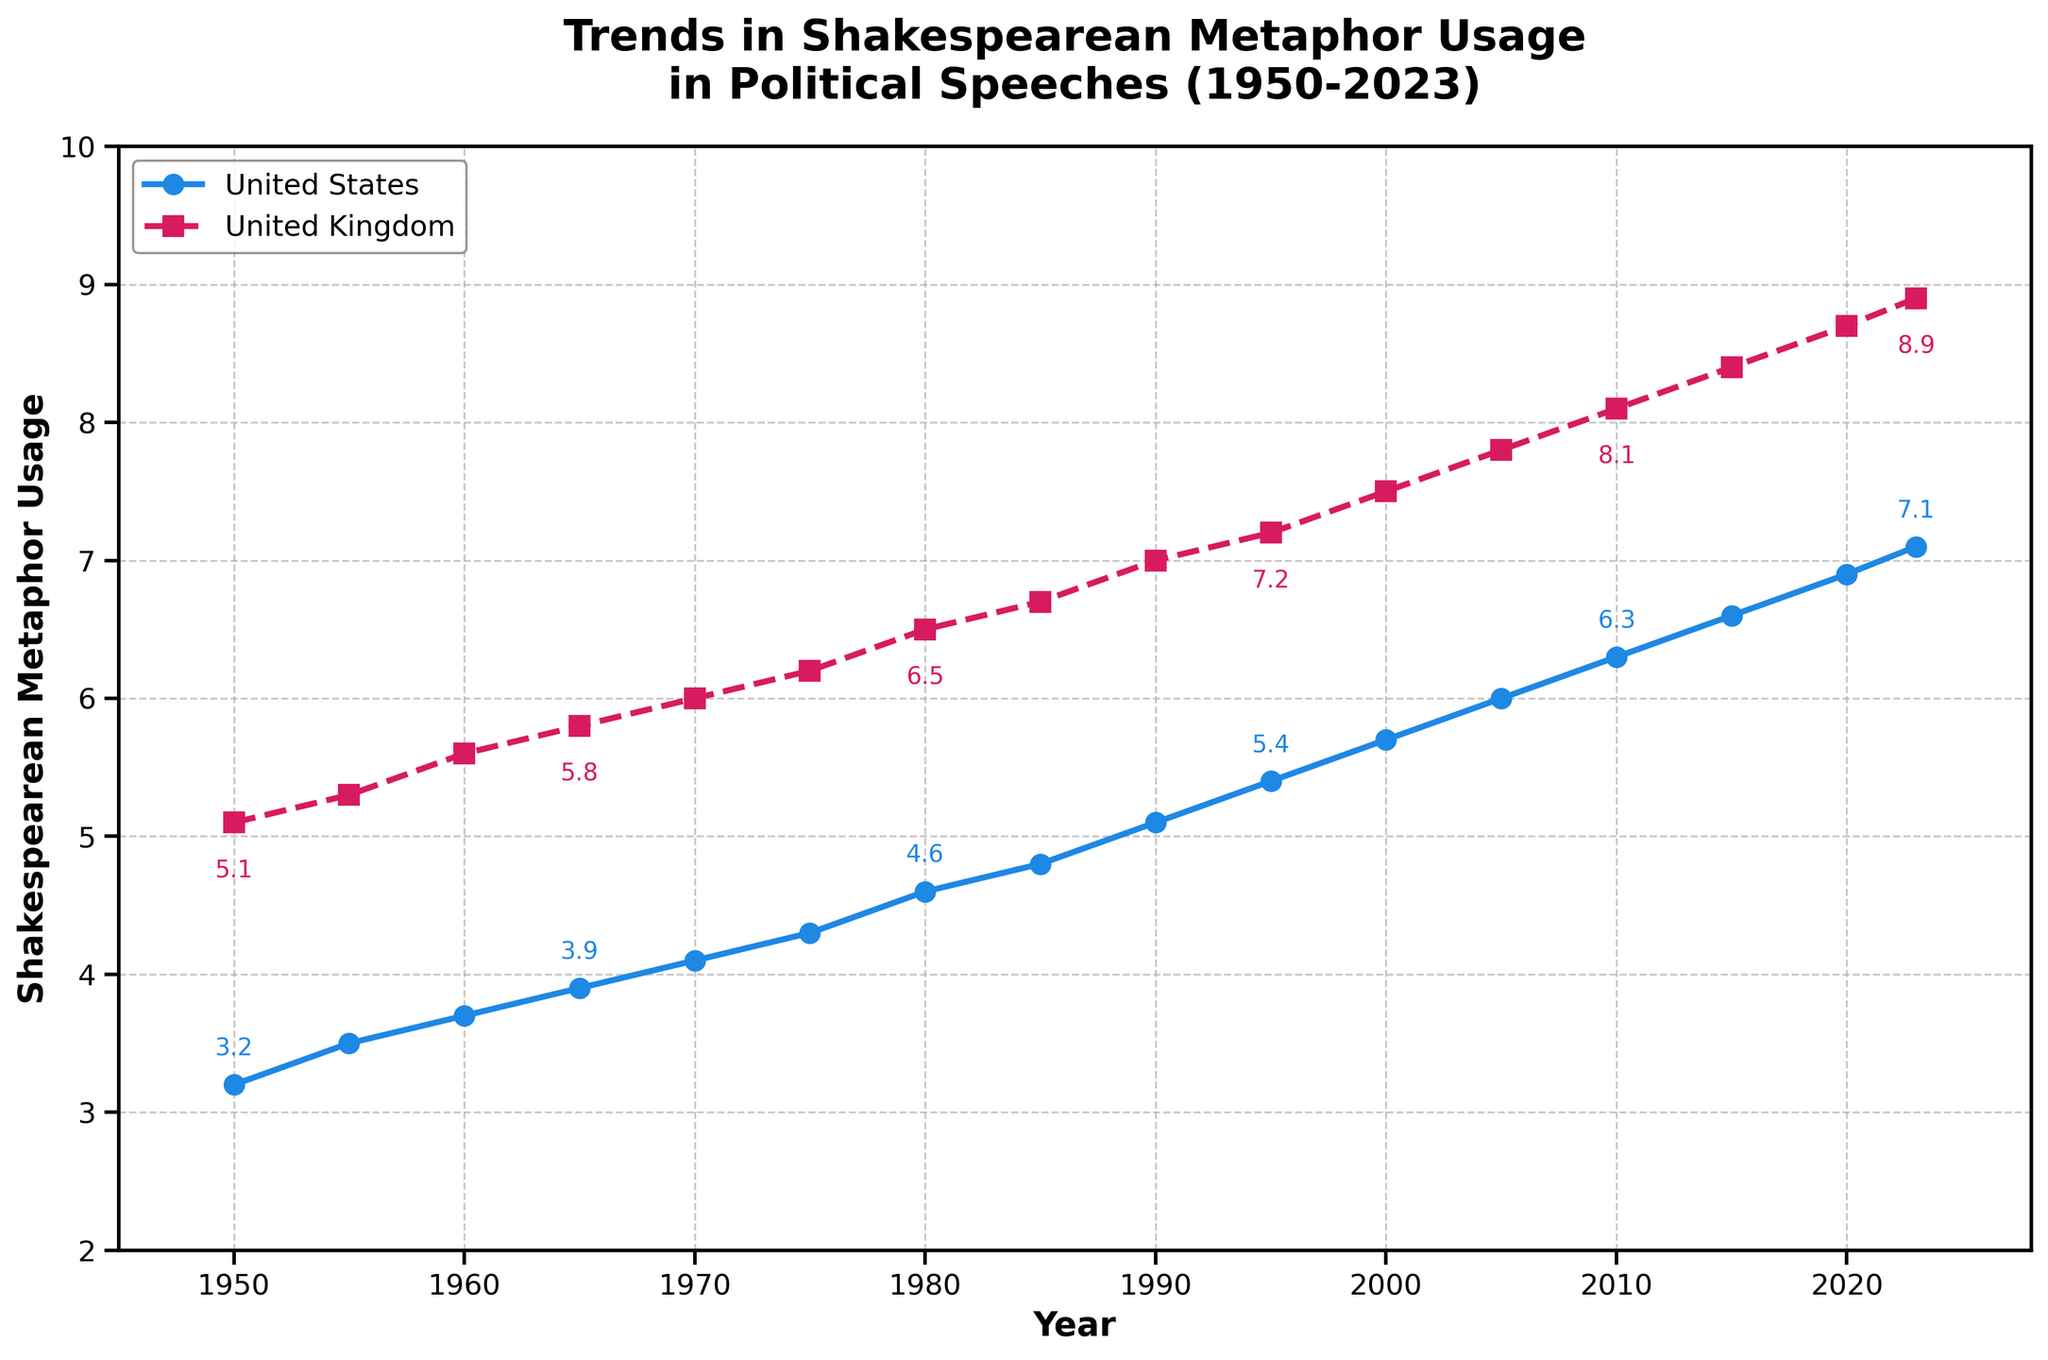What is the earliest year in which the Shakespearean metaphor usage in US political speeches reaches at least 6.0? From the chart, we identify the point where the US Metaphor Usage line first reaches or exceeds 6.0. This occurs at the year 2005, where the data shows 6.0.
Answer: 2005 Between 1980 and 2023, in which country did the Shakespearean metaphor usage increase at a faster rate? We need to calculate the difference between the data points for 1980 and 2023 for both countries. From 1980 to 2023, the US usage increased by (7.1 - 4.6) = 2.5, while the UK's increase was (8.9 - 6.5) = 2.4. The US had a slightly faster increase.
Answer: United States In which year did the UK first surpass 7.0 in Shakespearean metaphor usage in political speeches? We check the y-axis values for the UK's usage and the corresponding years. The first occurrence of UK usage surpassing 7.0 appears in 1990.
Answer: 1990 Between which consecutive years did the US see the largest increase in Shakespearean metaphor usage? To find the largest increase, we need to calculate the year-over-year difference for the US. The largest difference occurs between 2000 and 2005, where the usage increased by (6.0 - 5.7) = 0.3.
Answer: 2000-2005 In the year 2000, what was the difference in Shakespearean metaphor usage between the US and UK? For the year 2000, the usage in the US was 5.7 and in the UK was 7.5. The difference is (7.5 - 5.7) = 1.8.
Answer: 1.8 In each year provided, which country consistently had higher Shakespearean metaphor usage in political speeches? By examining all data points, the UK consistently had higher metaphor usage compared to the US every year.
Answer: United Kingdom What is the median value of Shakespearean metaphor usage in UK political speeches from 1950 to 2023? To find the median, we need to list all UK usage values: [5.1, 5.3, 5.6, 5.8, 6.0, 6.2, 6.5, 6.7, 7.0, 7.2, 7.5, 7.8, 8.1, 8.4, 8.7, 8.9]. The median is the average of the 8th and 9th values: (6.7 + 7.0)/2 = 6.85.
Answer: 6.85 